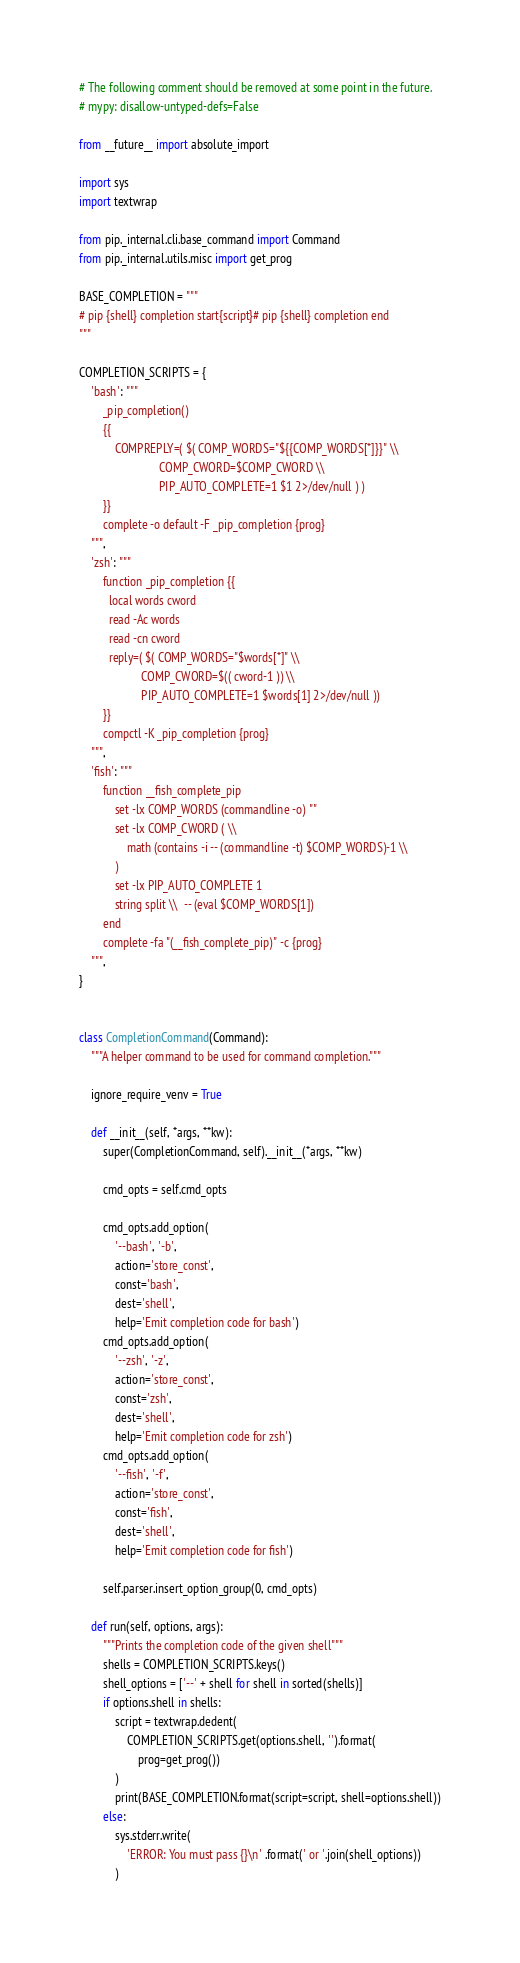Convert code to text. <code><loc_0><loc_0><loc_500><loc_500><_Python_># The following comment should be removed at some point in the future.
# mypy: disallow-untyped-defs=False

from __future__ import absolute_import

import sys
import textwrap

from pip._internal.cli.base_command import Command
from pip._internal.utils.misc import get_prog

BASE_COMPLETION = """
# pip {shell} completion start{script}# pip {shell} completion end
"""

COMPLETION_SCRIPTS = {
    'bash': """
        _pip_completion()
        {{
            COMPREPLY=( $( COMP_WORDS="${{COMP_WORDS[*]}}" \\
                           COMP_CWORD=$COMP_CWORD \\
                           PIP_AUTO_COMPLETE=1 $1 2>/dev/null ) )
        }}
        complete -o default -F _pip_completion {prog}
    """,
    'zsh': """
        function _pip_completion {{
          local words cword
          read -Ac words
          read -cn cword
          reply=( $( COMP_WORDS="$words[*]" \\
                     COMP_CWORD=$(( cword-1 )) \\
                     PIP_AUTO_COMPLETE=1 $words[1] 2>/dev/null ))
        }}
        compctl -K _pip_completion {prog}
    """,
    'fish': """
        function __fish_complete_pip
            set -lx COMP_WORDS (commandline -o) ""
            set -lx COMP_CWORD ( \\
                math (contains -i -- (commandline -t) $COMP_WORDS)-1 \\
            )
            set -lx PIP_AUTO_COMPLETE 1
            string split \\  -- (eval $COMP_WORDS[1])
        end
        complete -fa "(__fish_complete_pip)" -c {prog}
    """,
}


class CompletionCommand(Command):
    """A helper command to be used for command completion."""

    ignore_require_venv = True

    def __init__(self, *args, **kw):
        super(CompletionCommand, self).__init__(*args, **kw)

        cmd_opts = self.cmd_opts

        cmd_opts.add_option(
            '--bash', '-b',
            action='store_const',
            const='bash',
            dest='shell',
            help='Emit completion code for bash')
        cmd_opts.add_option(
            '--zsh', '-z',
            action='store_const',
            const='zsh',
            dest='shell',
            help='Emit completion code for zsh')
        cmd_opts.add_option(
            '--fish', '-f',
            action='store_const',
            const='fish',
            dest='shell',
            help='Emit completion code for fish')

        self.parser.insert_option_group(0, cmd_opts)

    def run(self, options, args):
        """Prints the completion code of the given shell"""
        shells = COMPLETION_SCRIPTS.keys()
        shell_options = ['--' + shell for shell in sorted(shells)]
        if options.shell in shells:
            script = textwrap.dedent(
                COMPLETION_SCRIPTS.get(options.shell, '').format(
                    prog=get_prog())
            )
            print(BASE_COMPLETION.format(script=script, shell=options.shell))
        else:
            sys.stderr.write(
                'ERROR: You must pass {}\n' .format(' or '.join(shell_options))
            )
</code> 